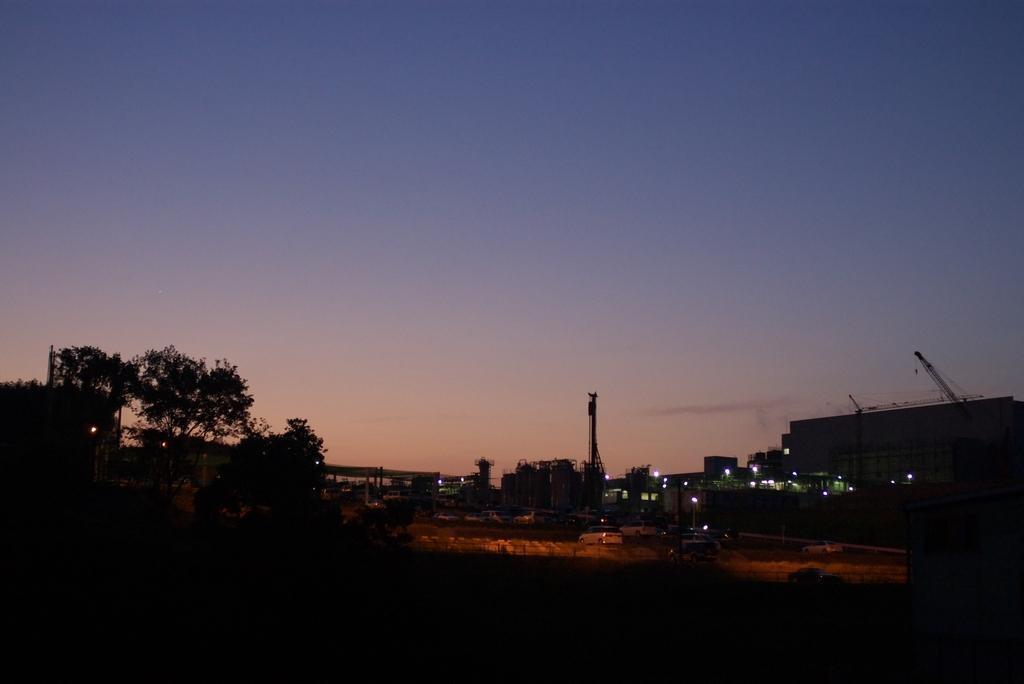Could you give a brief overview of what you see in this image? This is a night view of a city. In this image there are buildings, street lights, trees and the sky. 